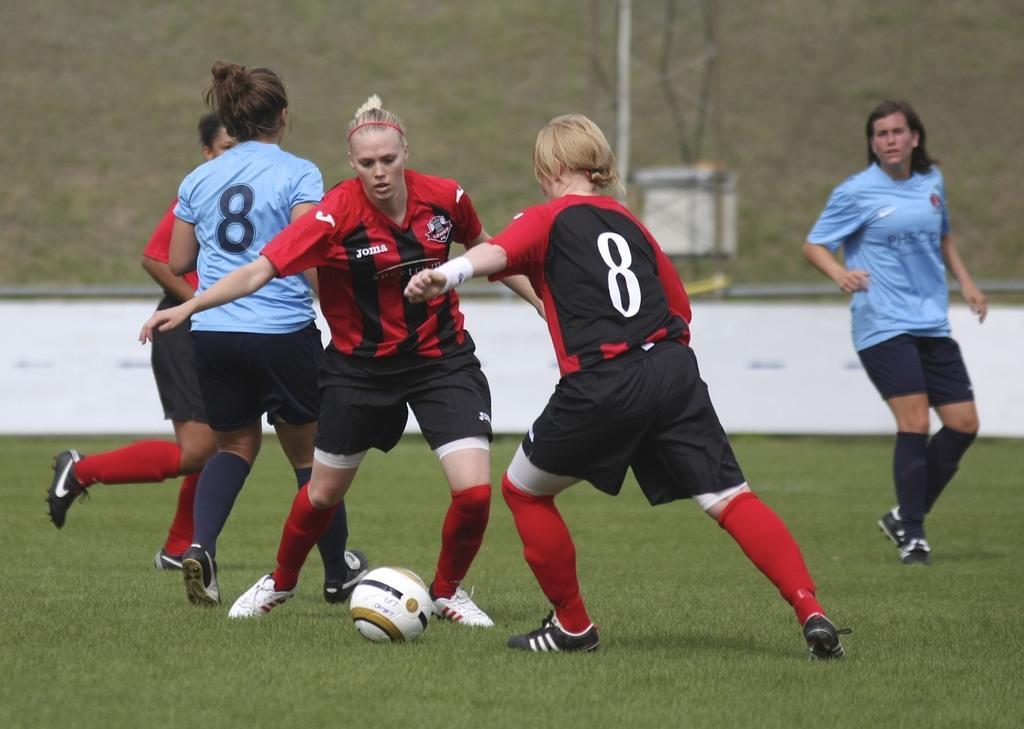What are the people in the image doing? The people in the image are playing. What object can be seen in the image that is commonly used in games? There is a ball in the image. What type of surface is visible in the image? There is grass in the image. What structures can be seen in the image? There is a wall and a pole in the image. Can you describe the unspecified object in the image? Unfortunately, the facts provided do not give any details about the unspecified object. How many friends are sitting on the chair in the image? There is no chair present in the image, so it is not possible to answer that question. 